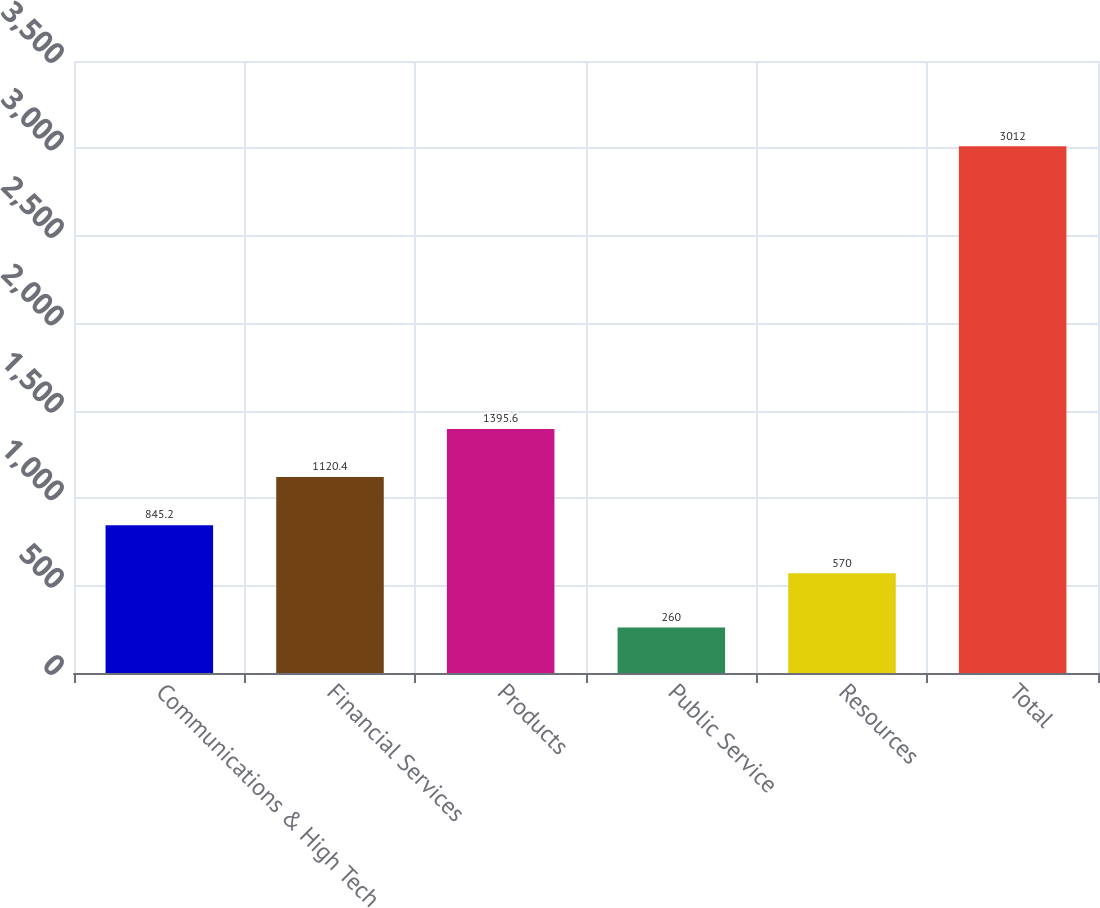<chart> <loc_0><loc_0><loc_500><loc_500><bar_chart><fcel>Communications & High Tech<fcel>Financial Services<fcel>Products<fcel>Public Service<fcel>Resources<fcel>Total<nl><fcel>845.2<fcel>1120.4<fcel>1395.6<fcel>260<fcel>570<fcel>3012<nl></chart> 